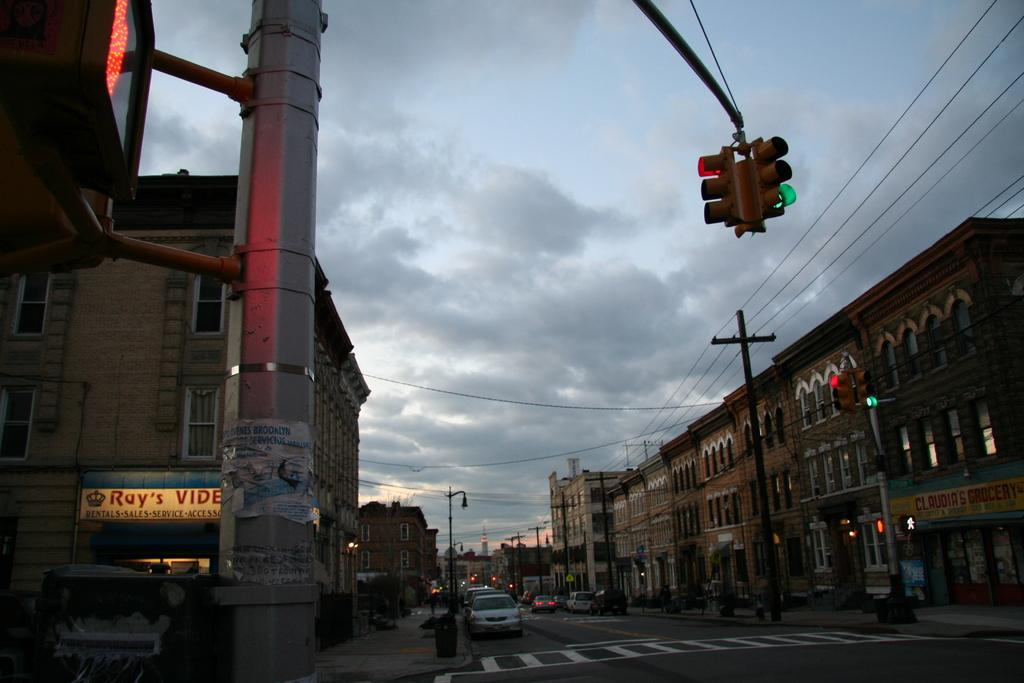<image>
Provide a brief description of the given image. An intersection with a traffic light glowing in red and green with an establishment called ray's video in the background. 